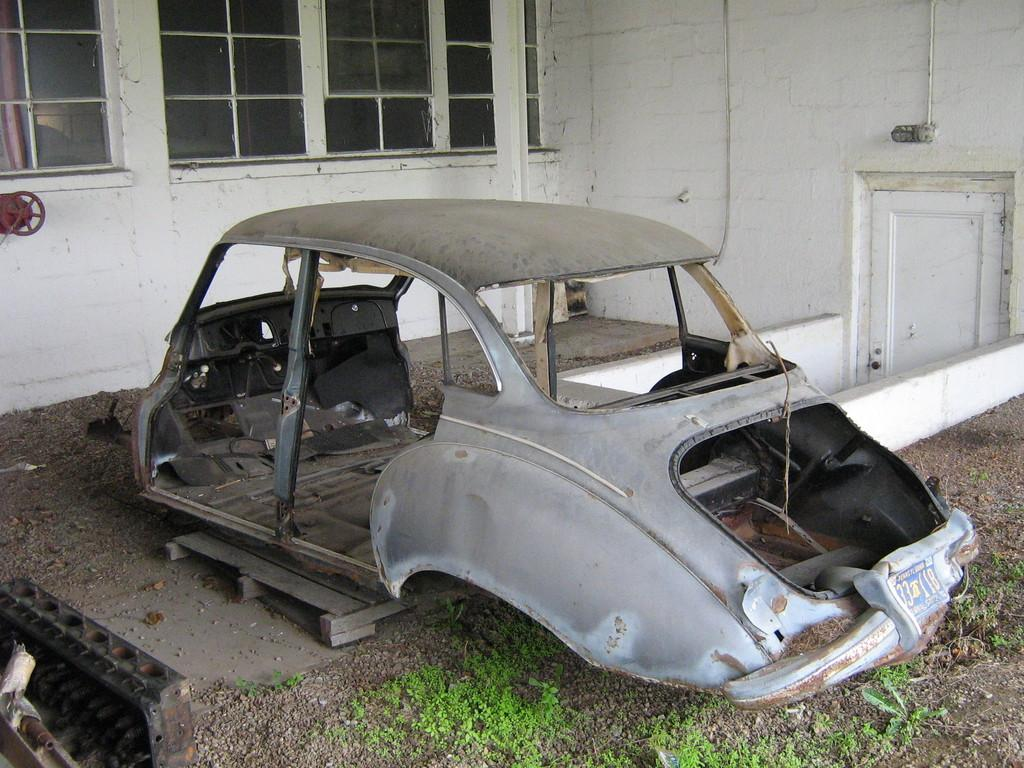What is the main subject of the image? There is a vehicle body in the image. What other elements can be seen in the image besides the vehicle body? There are plants, glass windows, a wall, and a door visible in the image. Can you describe the background of the image? The background of the image includes glass windows and a wall. What is the purpose of the door in the image? The door in the image is likely for entering or exiting the space where the vehicle body is located. What statement does the name of the vehicle body make in the image? There is no statement or name associated with the vehicle body in the image. What is the size of the vehicle body in the image? The size of the vehicle body cannot be determined from the image alone. 